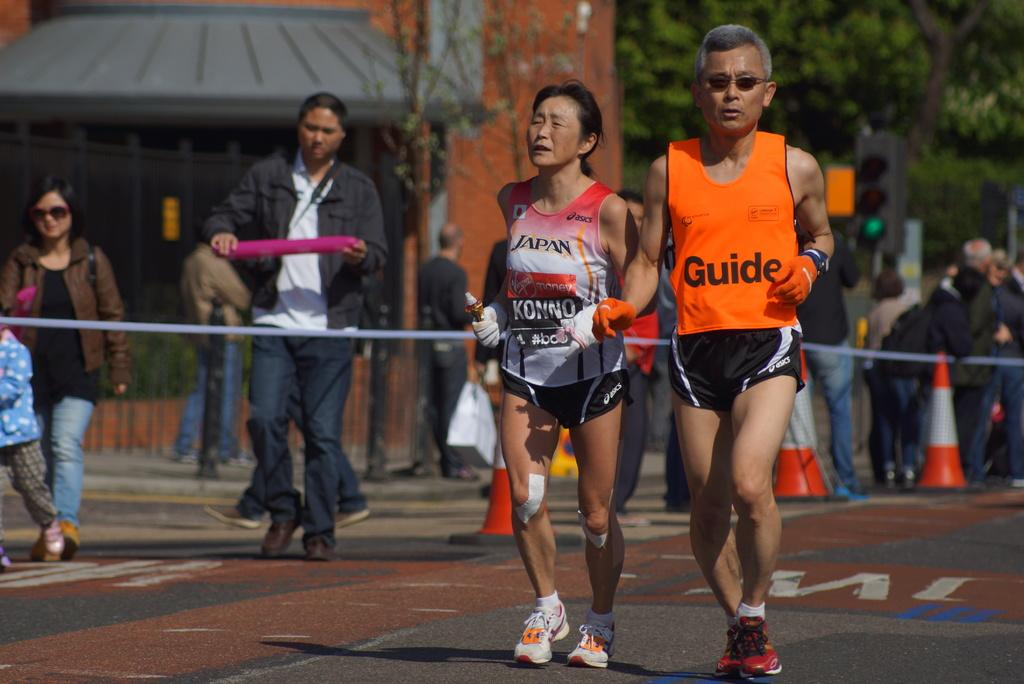<image>
Relay a brief, clear account of the picture shown. Two runners, one appears to be the guide for the runner that says Japan on her jersey. 